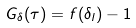<formula> <loc_0><loc_0><loc_500><loc_500>G _ { \delta } ( \tau ) = f ( \delta _ { l } ) - 1</formula> 